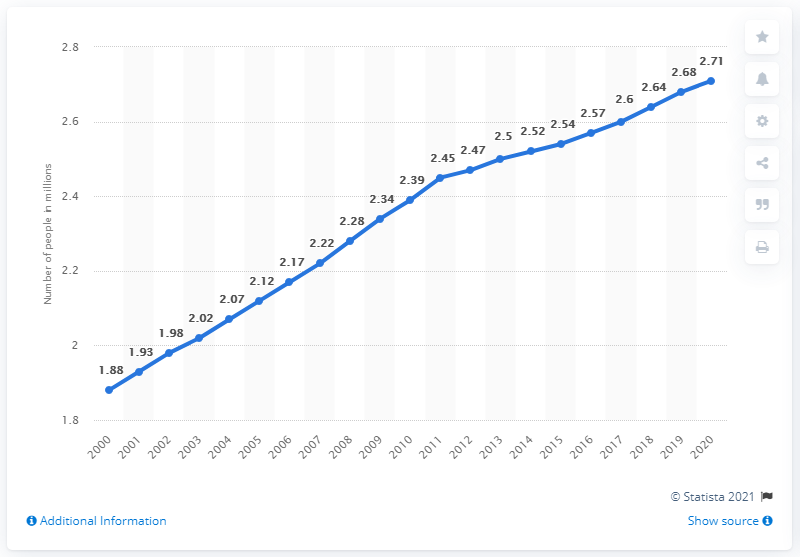List a handful of essential elements in this visual. As of 2020, it is estimated that approximately 2.71 million individuals in Canada had obtained a legal divorce but had not yet remarried. In 2000, there were 1.88 million divorcees in Canada. As of 2020, an estimated 2.71 million people in Canada have experienced a divorce. According to statistics, there were approximately 3.81 million individuals who were divorced in Canada between the years 2000 and 2001. 